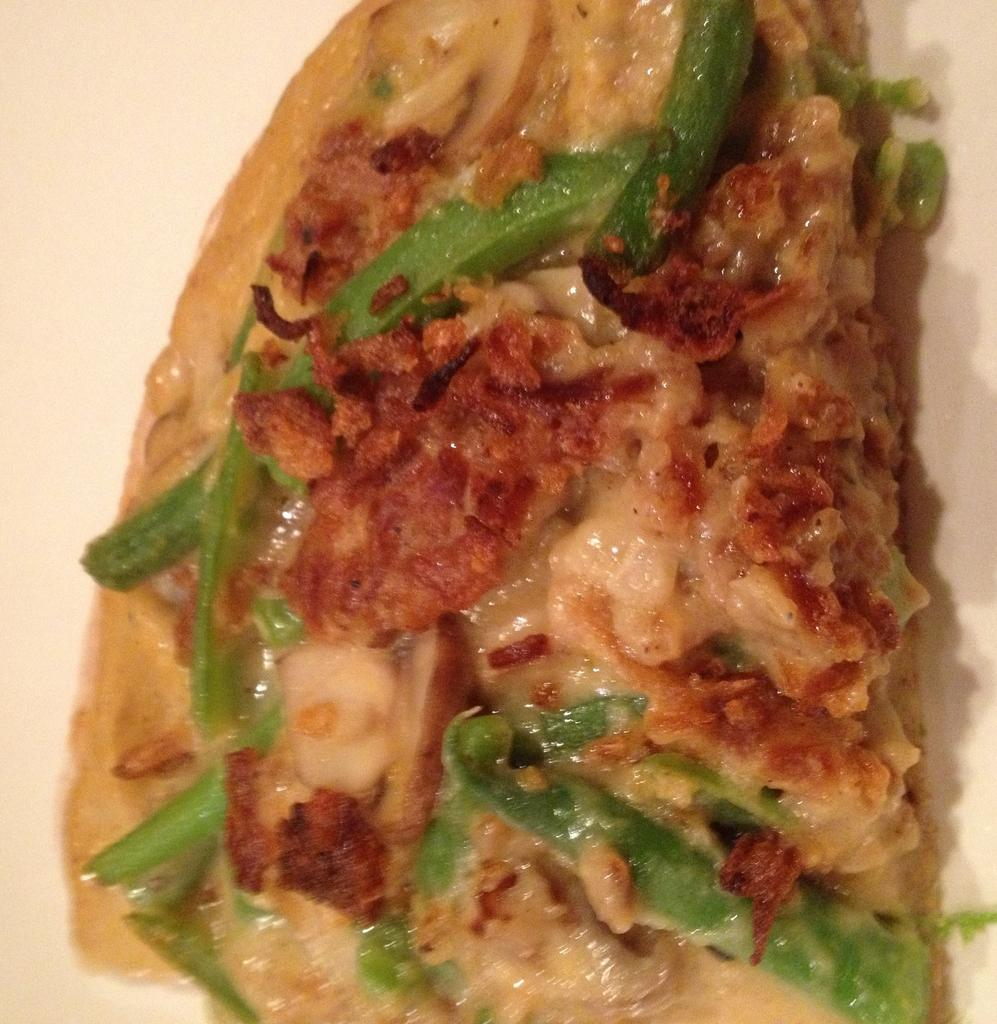What type of food is shown in the image? There is a slice of pizza in the image. What topping can be seen on the pizza slice? The pizza slice is decorated with capsicum. What type of mine is shown in the image? There is no mine present in the image; it features a slice of pizza with capsicum. What kind of doll is holding the bait in the image? There is no doll or bait present in the image. 